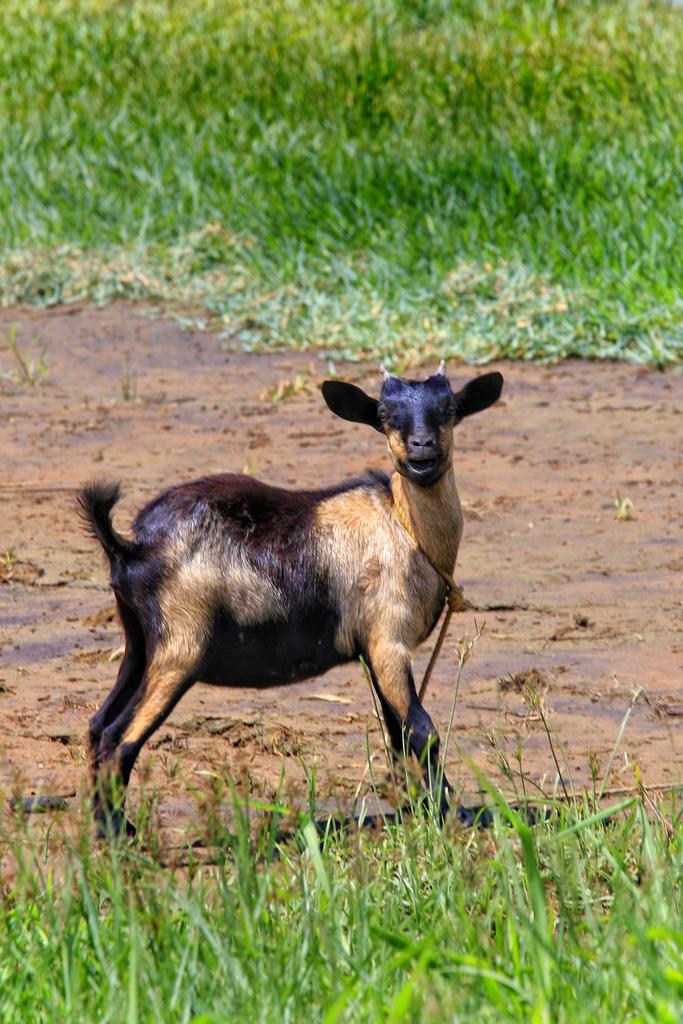What animal is present in the picture? There is a sheep in the picture. What is the sheep doing in the picture? The sheep is standing and looking at something. What type of vegetation is visible at the bottom of the image? There is grass at the bottom of the image. What can be seen in the background of the image? There is grass visible in the background of the image. What effect does the creator of the image have on the sheep's behavior? There is no information about a creator in the image, and therefore no effect on the sheep's behavior can be determined. 